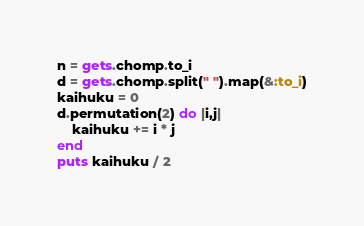Convert code to text. <code><loc_0><loc_0><loc_500><loc_500><_Ruby_>n = gets.chomp.to_i
d = gets.chomp.split(" ").map(&:to_i)
kaihuku = 0
d.permutation(2) do |i,j|
    kaihuku += i * j
end
puts kaihuku / 2</code> 